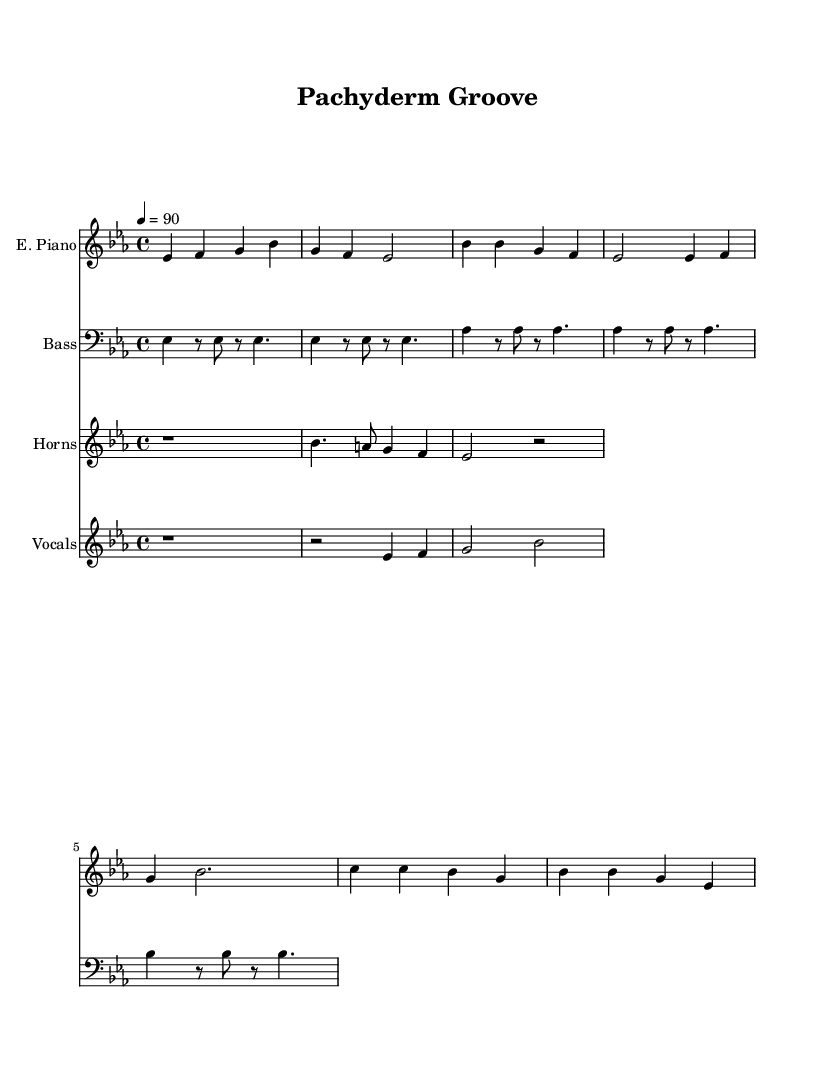What is the key signature of this music? The key signature is E flat major, which has three flats (B flat, E flat, and A flat). This can be determined by the key signature notation at the beginning of the staff.
Answer: E flat major What is the time signature of this music? The time signature is 4/4, indicated at the beginning of the score, which tells us that there are four beats in a measure.
Answer: 4/4 What is the tempo marking of this piece? The tempo marking is 90 beats per minute, indicated as "4 = 90," which means the quarter note (4) should be played at 90 beats per minute.
Answer: 90 How many measures are in the intro section? The intro section consists of 4 measures, which can be counted by analyzing the notation provided for the electric piano part.
Answer: 4 What is the first note played by the trumpet? The first note played by the trumpet is a rest, indicated by the "r" notation that appears at the start of the trumpet line.
Answer: rest Which instrument has the highest pitch overall in this piece? The instrument with the highest pitch overall is the trumpet, which plays notes in the higher octave relative to the other instruments shown in the score.
Answer: trumpet 